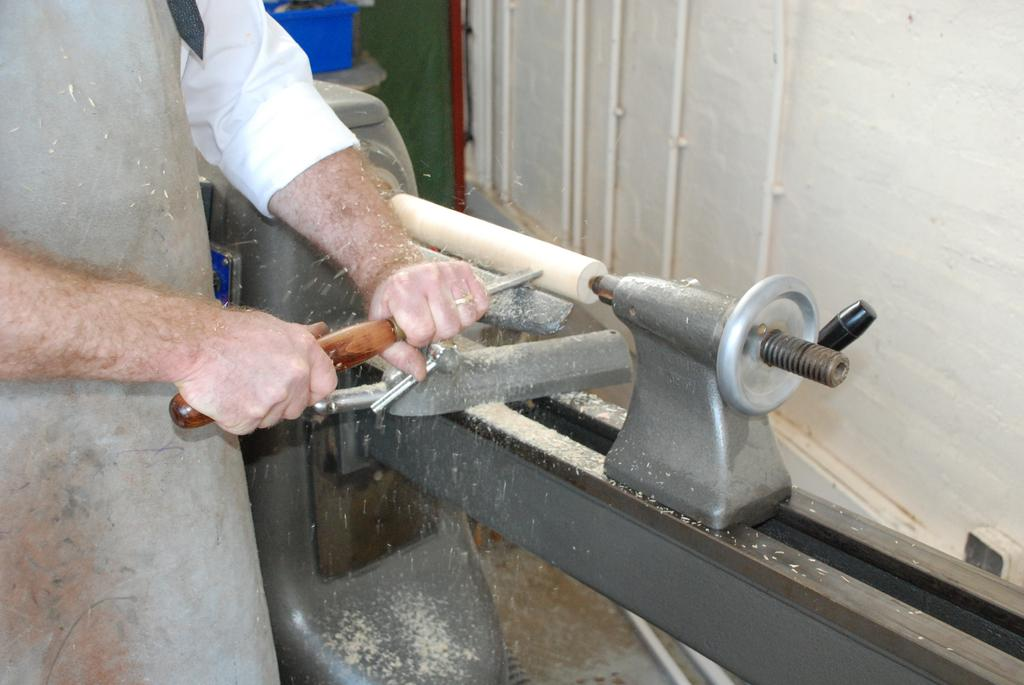What can be seen in the image? There is a person in the image. What is the person holding? The person is holding an object. Can you describe the mechanical instrument in the image? There is a mechanical instrument in the image. What is visible in the background of the image? There is a wall visible in the image. What type of space-related object is hanging from the person's neck in the image? There is no space-related object, such as a locket, hanging from the person's neck in the image. 